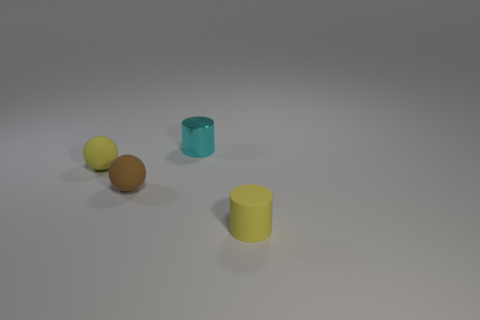Add 3 tiny cyan shiny things. How many objects exist? 7 Subtract all green cubes. Subtract all rubber objects. How many objects are left? 1 Add 2 yellow things. How many yellow things are left? 4 Add 1 gray things. How many gray things exist? 1 Subtract 0 blue blocks. How many objects are left? 4 